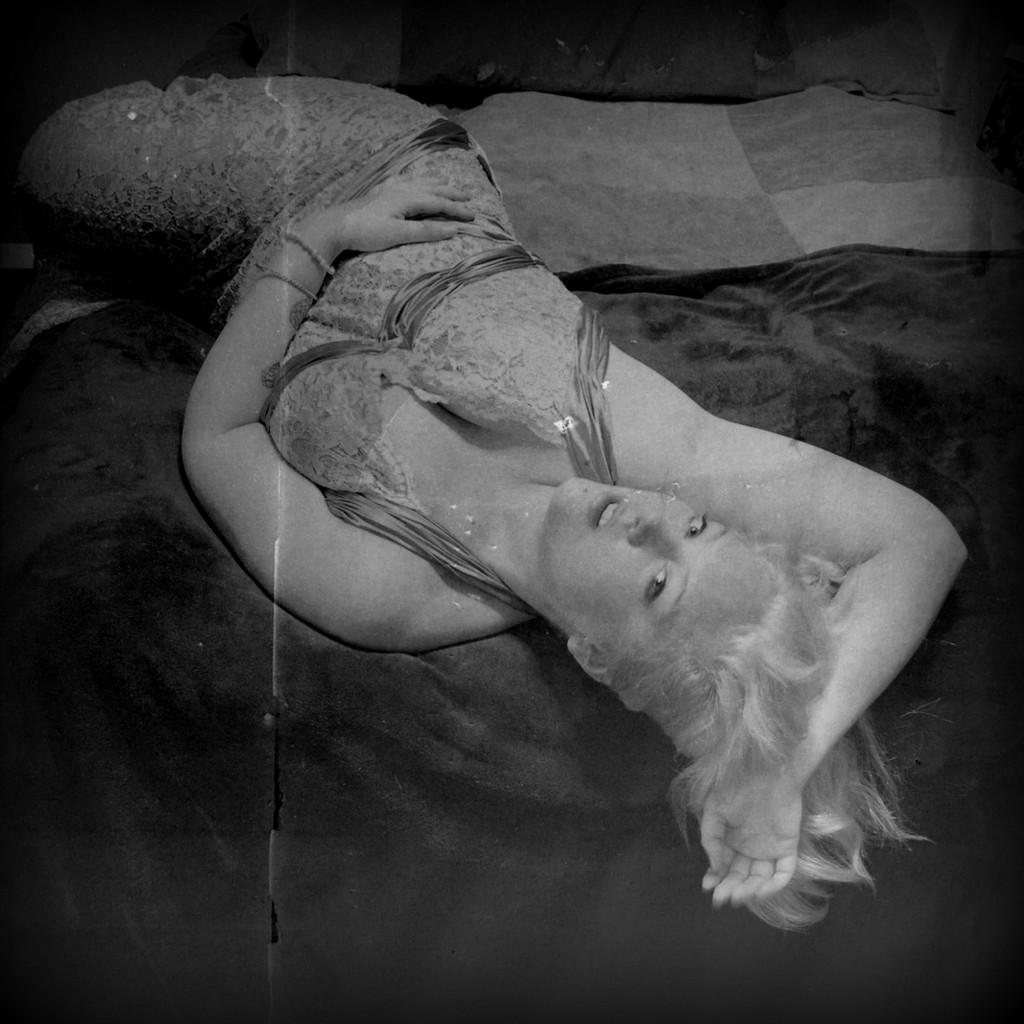Please provide a concise description of this image. In this picture I can see a woman laying on the bed and I can see a black color cloth. 